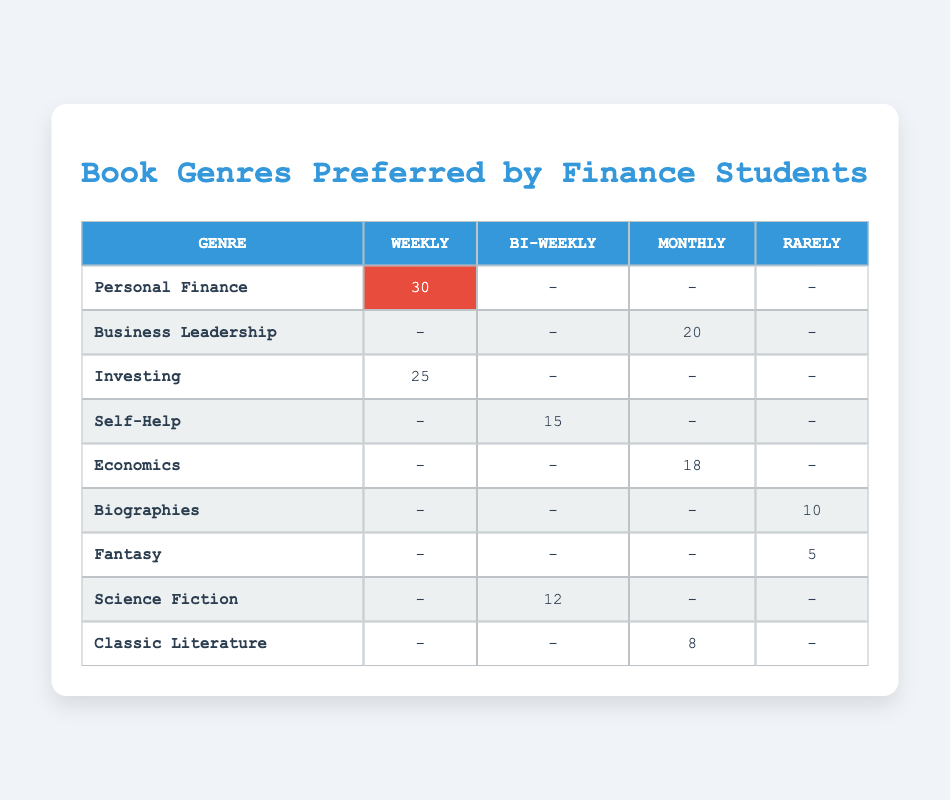What is the most preferred genre among finance students based on the reading frequency? The most preferred genre can be identified by looking for the highest count in the 'Weekly' category. The 'Personal Finance' genre has a count of 30, which is higher than any other genre for the 'Weekly' reading frequency.
Answer: Personal Finance How many finance students read 'Investing' books weekly? Referring directly to the crosstab, the count under the 'Investing' genre for the 'Weekly' frequency is 25.
Answer: 25 What is the total count of books read by finance students on a bi-weekly basis? To find the total count for bi-weekly reading frequency, only the counts for 'Self-Help' (15) and 'Science Fiction' (12) apply. Adding them gives: 15 + 12 = 27.
Answer: 27 Are there any genres that finance students read rarely? There are two genres listed under 'Rarely' which are 'Biographies' and 'Fantasy'. Since there are counts for both, the answer is yes; they do read genres rarely.
Answer: Yes How many genres are read monthly by finance students, and which are they? The genres and their corresponding counts for 'Monthly' are 'Business Leadership' (20), 'Economics' (18), and 'Classic Literature' (8). This indicates three genres are read monthly.
Answer: 3 genres: Business Leadership, Economics, Classic Literature What is the difference in counts between the most widely read genre and the least read genre? The most widely read genre is 'Personal Finance' with 30 counts, while the least read genre is 'Fantasy' with 5 counts. Therefore, the difference is 30 - 5 = 25.
Answer: 25 What reading frequency is least preferred by finance students? To determine this, we can look for the lowest count across all genres in all reading frequencies. The least count found is for 'Fantasy', which has 5 under 'Rarely', indicating that the least preferred is 'Rarely'.
Answer: Rarely What percentage of finance students read 'Self-Help' books bi-weekly compared to those that read 'Personal Finance' weekly? The count for 'Self-Help' is 15 and for 'Personal Finance' is 30, which means: (15 / (15 + 30)) * 100 = 33.33%. This indicates that about 33.3% read 'Self-Help' bi-weekly compared to 'Personal Finance'.
Answer: 33.3% 